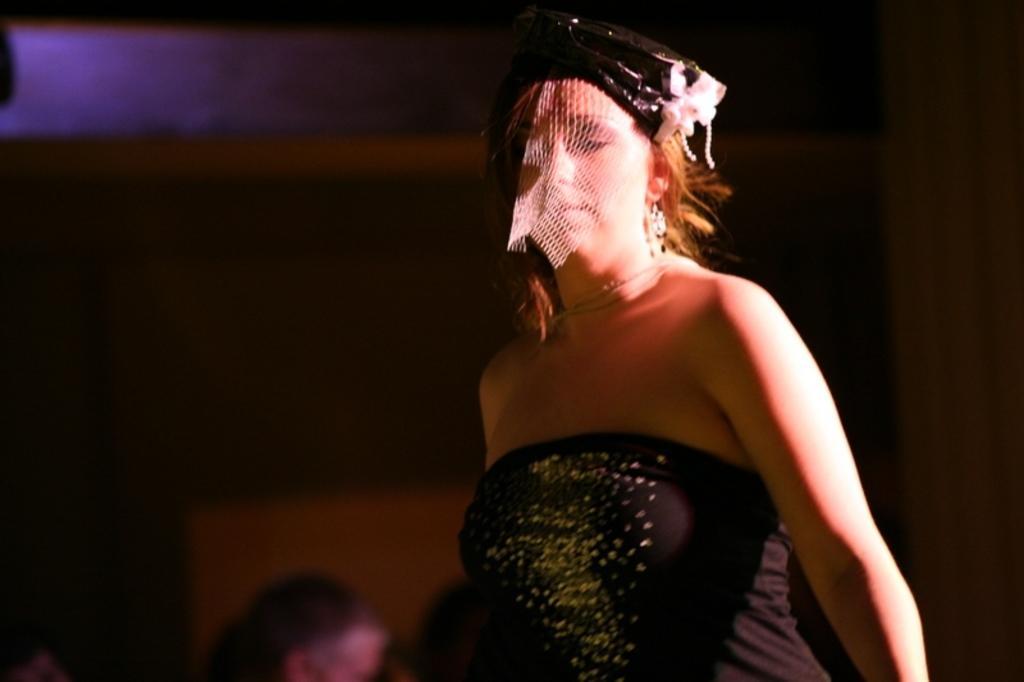Could you give a brief overview of what you see in this image? In this image we can see a lady wearing cap and mask. In the background it is dark. 